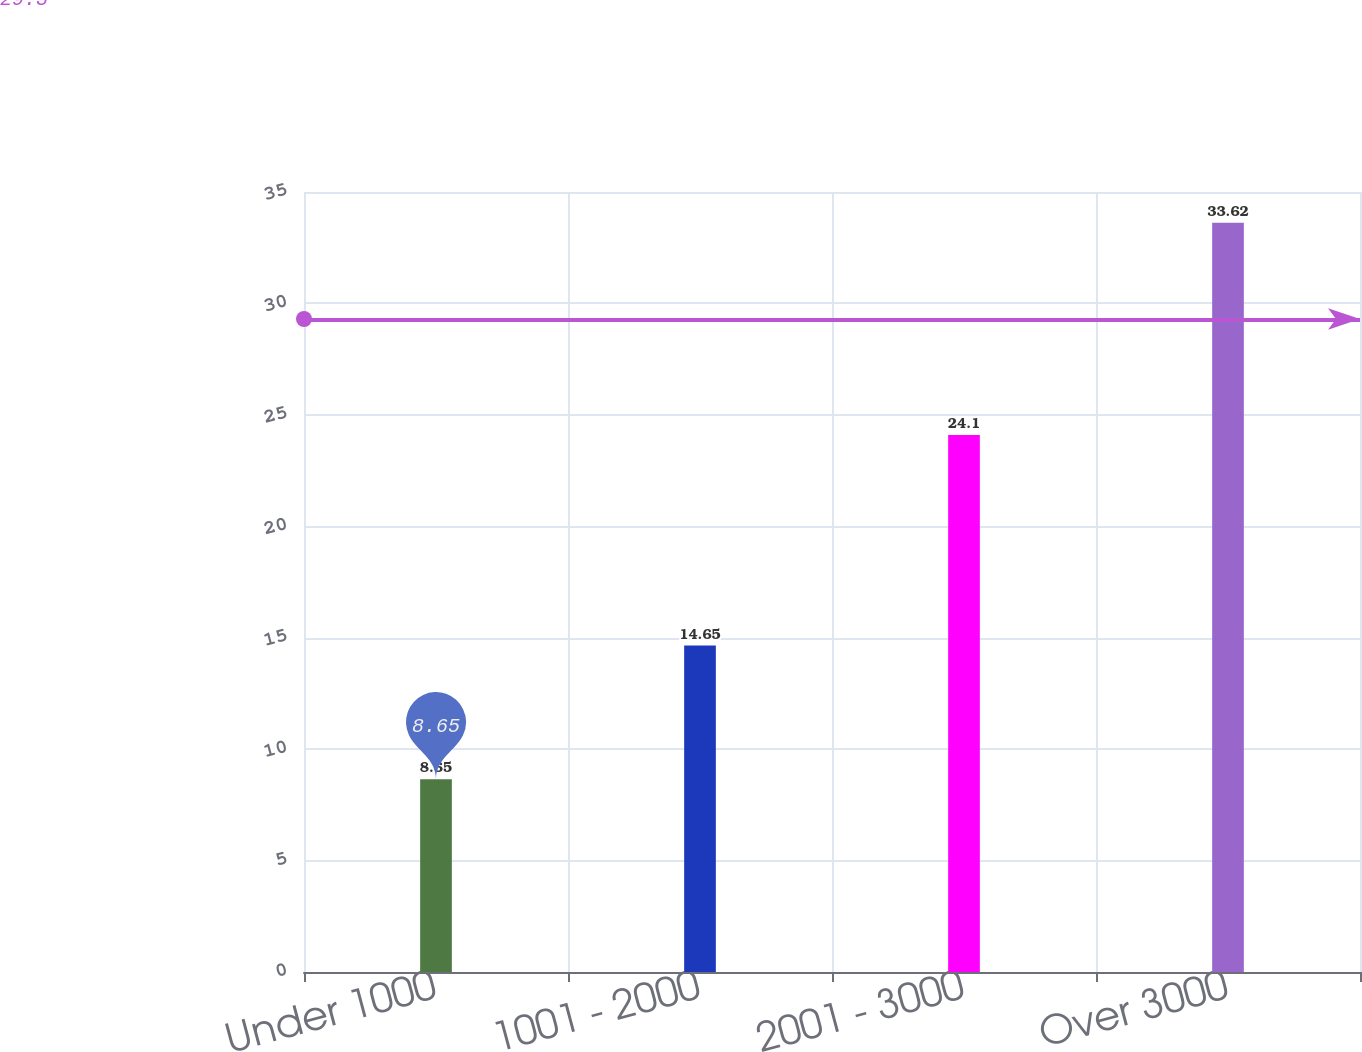<chart> <loc_0><loc_0><loc_500><loc_500><bar_chart><fcel>Under 1000<fcel>1001 - 2000<fcel>2001 - 3000<fcel>Over 3000<nl><fcel>8.65<fcel>14.65<fcel>24.1<fcel>33.62<nl></chart> 